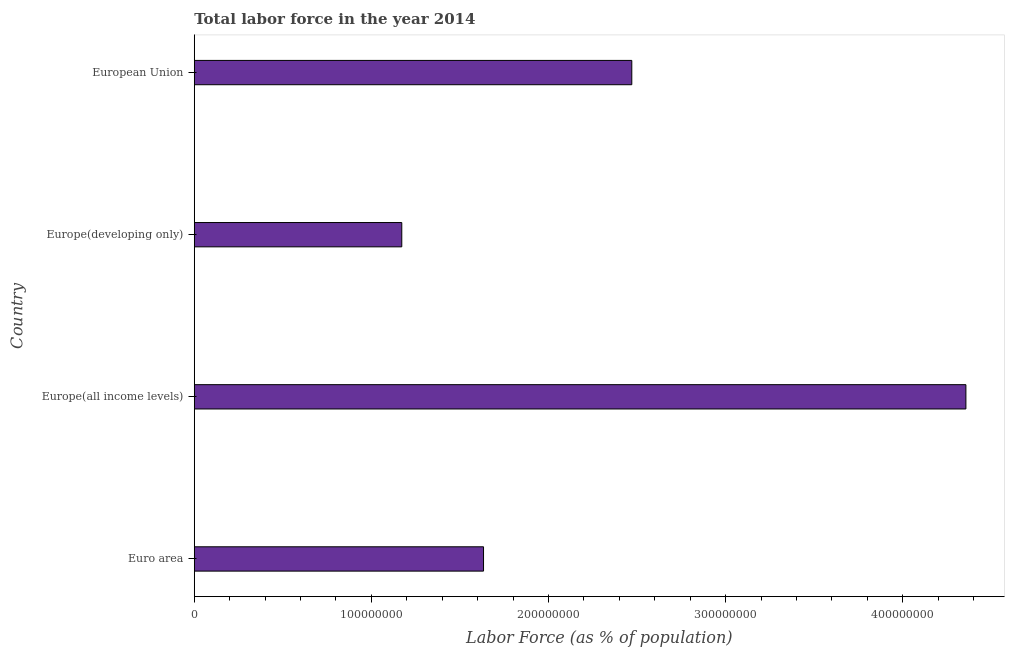Does the graph contain any zero values?
Your response must be concise. No. Does the graph contain grids?
Offer a terse response. No. What is the title of the graph?
Make the answer very short. Total labor force in the year 2014. What is the label or title of the X-axis?
Provide a succinct answer. Labor Force (as % of population). What is the label or title of the Y-axis?
Your answer should be very brief. Country. What is the total labor force in Europe(all income levels)?
Ensure brevity in your answer.  4.36e+08. Across all countries, what is the maximum total labor force?
Offer a very short reply. 4.36e+08. Across all countries, what is the minimum total labor force?
Keep it short and to the point. 1.17e+08. In which country was the total labor force maximum?
Keep it short and to the point. Europe(all income levels). In which country was the total labor force minimum?
Keep it short and to the point. Europe(developing only). What is the sum of the total labor force?
Keep it short and to the point. 9.63e+08. What is the difference between the total labor force in Euro area and Europe(all income levels)?
Offer a terse response. -2.72e+08. What is the average total labor force per country?
Provide a short and direct response. 2.41e+08. What is the median total labor force?
Provide a short and direct response. 2.05e+08. In how many countries, is the total labor force greater than 120000000 %?
Your answer should be compact. 3. What is the ratio of the total labor force in Europe(all income levels) to that in Europe(developing only)?
Your response must be concise. 3.72. Is the difference between the total labor force in Europe(developing only) and European Union greater than the difference between any two countries?
Make the answer very short. No. What is the difference between the highest and the second highest total labor force?
Provide a succinct answer. 1.89e+08. Is the sum of the total labor force in Euro area and European Union greater than the maximum total labor force across all countries?
Provide a succinct answer. No. What is the difference between the highest and the lowest total labor force?
Your answer should be very brief. 3.18e+08. What is the Labor Force (as % of population) in Euro area?
Your answer should be compact. 1.63e+08. What is the Labor Force (as % of population) of Europe(all income levels)?
Your response must be concise. 4.36e+08. What is the Labor Force (as % of population) in Europe(developing only)?
Ensure brevity in your answer.  1.17e+08. What is the Labor Force (as % of population) in European Union?
Your response must be concise. 2.47e+08. What is the difference between the Labor Force (as % of population) in Euro area and Europe(all income levels)?
Provide a succinct answer. -2.72e+08. What is the difference between the Labor Force (as % of population) in Euro area and Europe(developing only)?
Offer a terse response. 4.62e+07. What is the difference between the Labor Force (as % of population) in Euro area and European Union?
Give a very brief answer. -8.37e+07. What is the difference between the Labor Force (as % of population) in Europe(all income levels) and Europe(developing only)?
Offer a very short reply. 3.18e+08. What is the difference between the Labor Force (as % of population) in Europe(all income levels) and European Union?
Offer a terse response. 1.89e+08. What is the difference between the Labor Force (as % of population) in Europe(developing only) and European Union?
Offer a terse response. -1.30e+08. What is the ratio of the Labor Force (as % of population) in Euro area to that in Europe(all income levels)?
Your answer should be compact. 0.38. What is the ratio of the Labor Force (as % of population) in Euro area to that in Europe(developing only)?
Your response must be concise. 1.39. What is the ratio of the Labor Force (as % of population) in Euro area to that in European Union?
Ensure brevity in your answer.  0.66. What is the ratio of the Labor Force (as % of population) in Europe(all income levels) to that in Europe(developing only)?
Give a very brief answer. 3.72. What is the ratio of the Labor Force (as % of population) in Europe(all income levels) to that in European Union?
Offer a very short reply. 1.76. What is the ratio of the Labor Force (as % of population) in Europe(developing only) to that in European Union?
Provide a short and direct response. 0.47. 